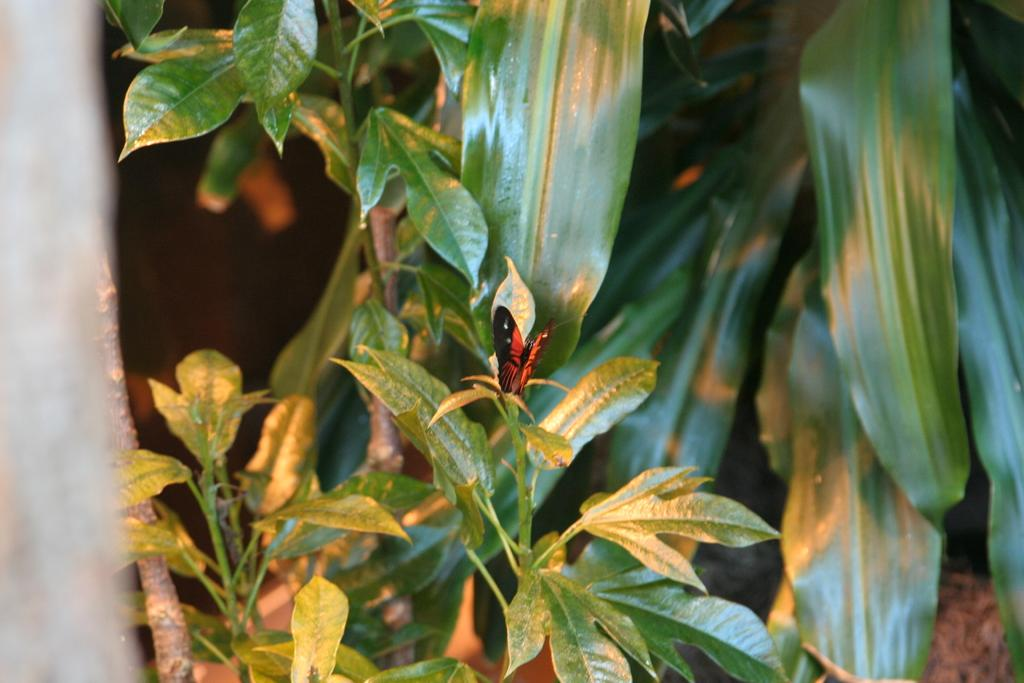What is the main subject of the image? There is a butterfly in the image. Where is the butterfly located in the image? The butterfly is sitting on a plant. What else can be seen in the image besides the butterfly? Leaves and other plants are visible in the image. What type of apparatus is being used to create a rainstorm in the image? There is no apparatus or rainstorm present in the image; it features a butterfly sitting on a plant. Is there any poison visible in the image? There is no poison present in the image; it features a butterfly sitting on a plant. 